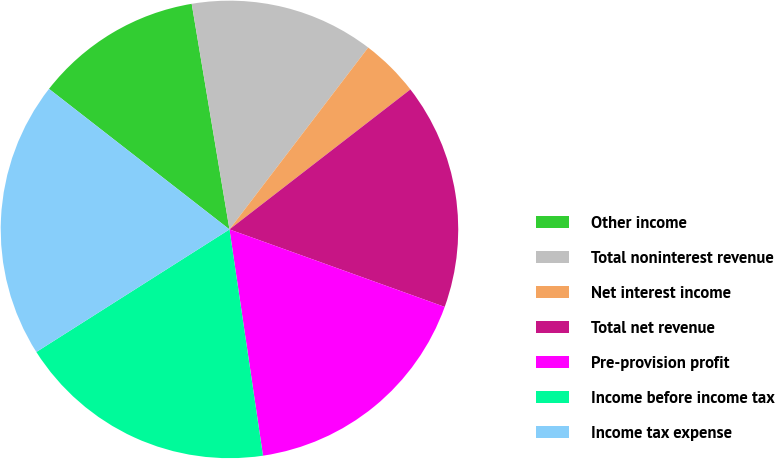Convert chart. <chart><loc_0><loc_0><loc_500><loc_500><pie_chart><fcel>Other income<fcel>Total noninterest revenue<fcel>Net interest income<fcel>Total net revenue<fcel>Pre-provision profit<fcel>Income before income tax<fcel>Income tax expense<nl><fcel>11.83%<fcel>13.01%<fcel>4.15%<fcel>15.98%<fcel>17.16%<fcel>18.34%<fcel>19.53%<nl></chart> 